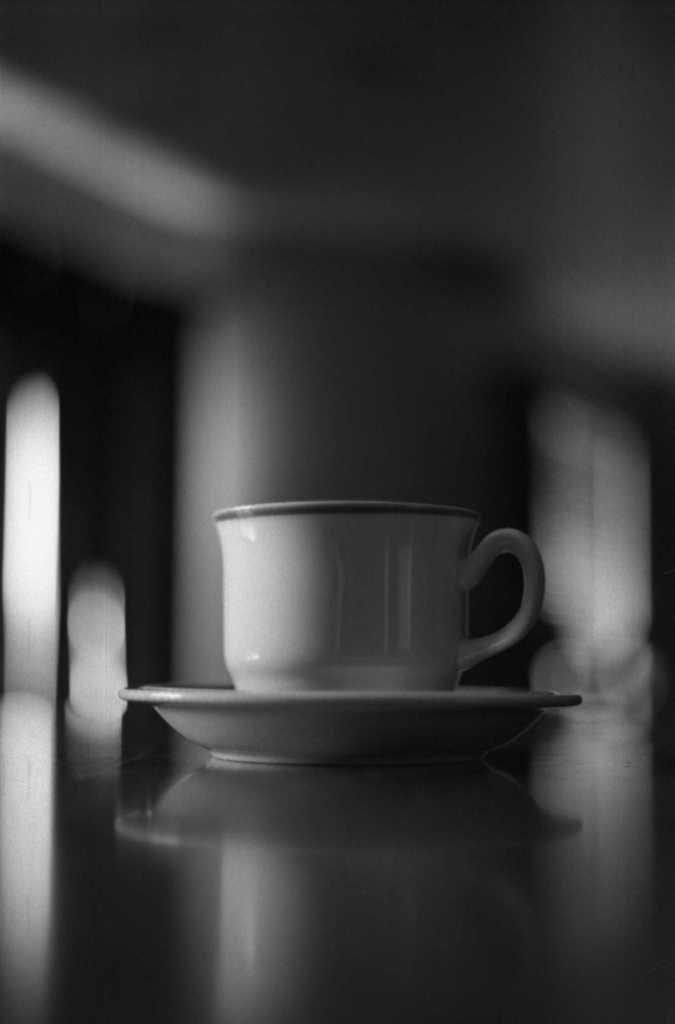Could you give a brief overview of what you see in this image? This image is a black and white image. This image is taken indoors. At the bottom of the image there is a table. In this image the background is a little blurred. In the middle of the image there is a cup and a saucer on the table. 